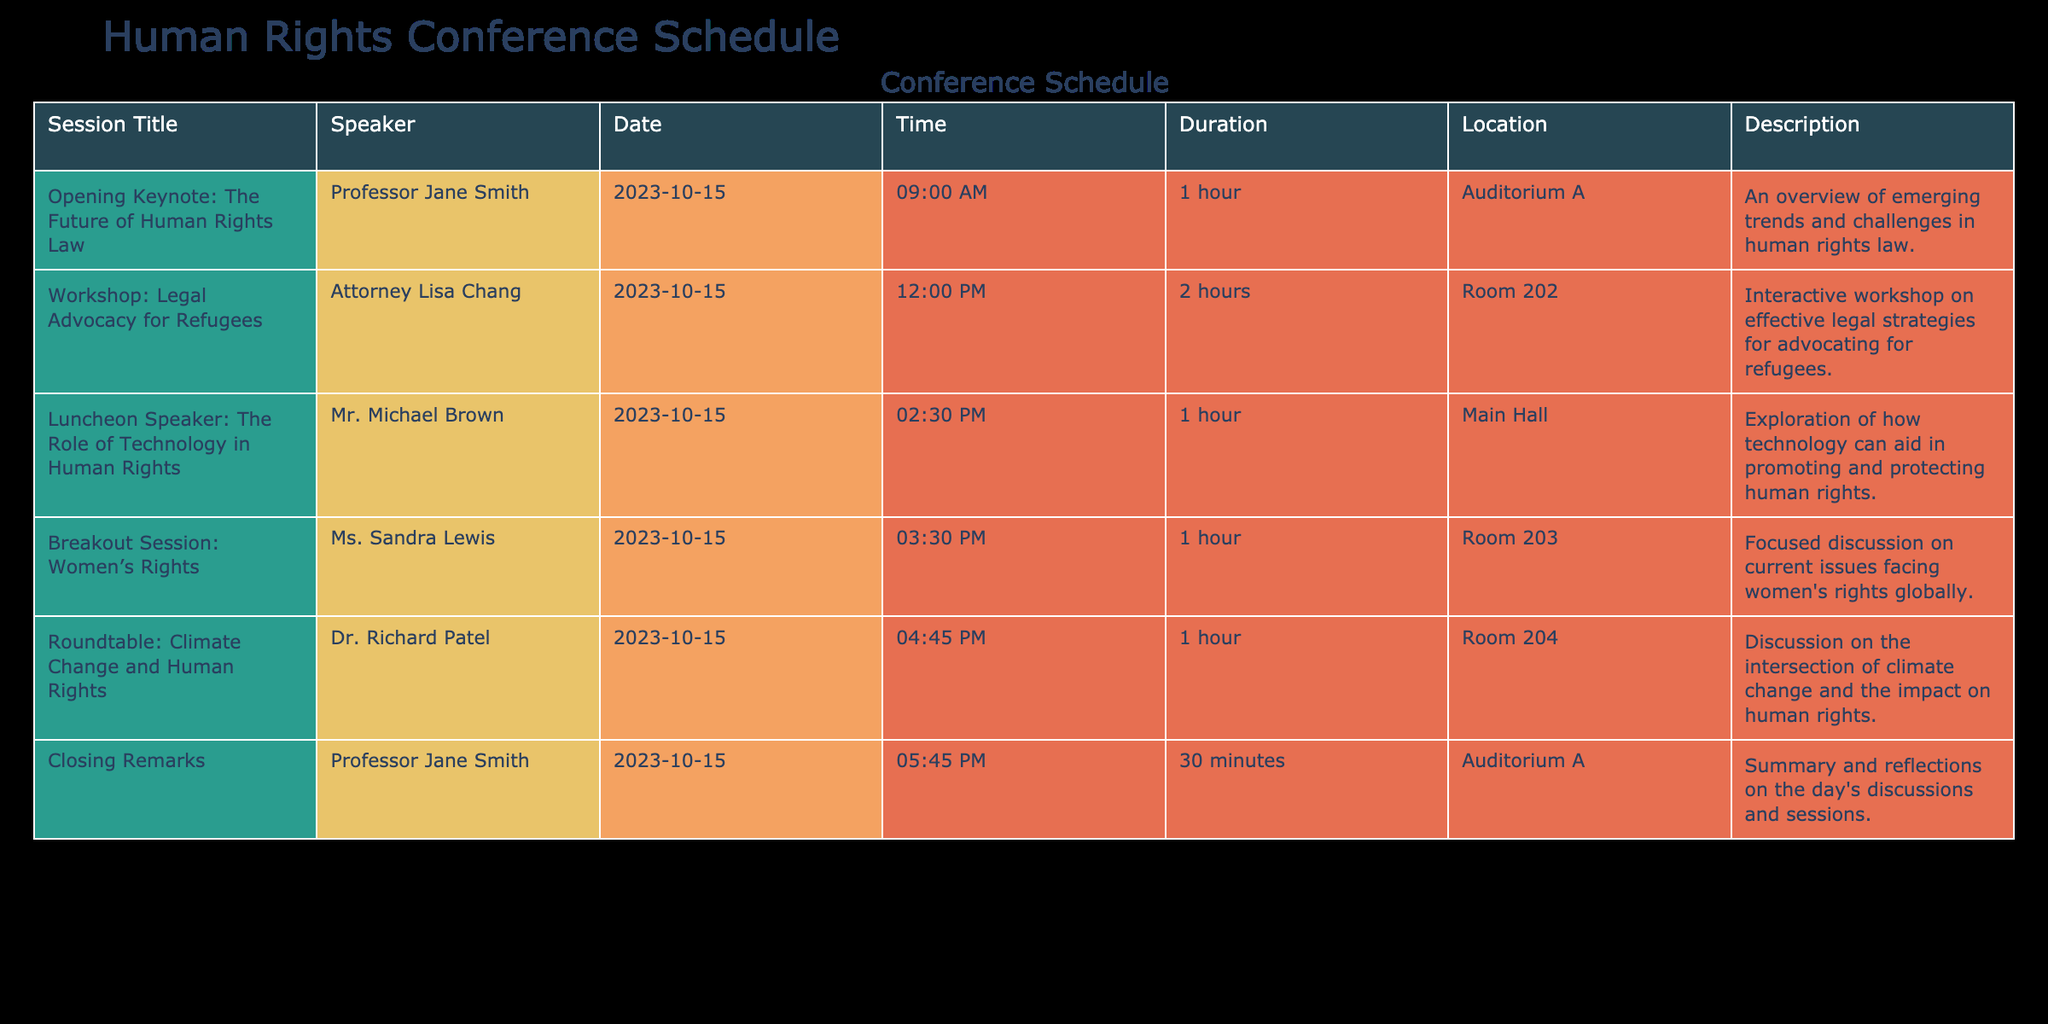What is the title of the opening keynote session? The title of the opening keynote session is listed in the first row of the table under the column "Session Title." It reads "Opening Keynote: The Future of Human Rights Law."
Answer: Opening Keynote: The Future of Human Rights Law Who is the speaker for the workshop on legal advocacy for refugees? The speaker's name is found in the second row of the table under the column "Speaker." The speaker for the workshop is Attorney Lisa Chang.
Answer: Attorney Lisa Chang What is the total duration of the sessions scheduled for October 15, 2023? To find the total duration, we can sum the duration of each session. The durations are 1 hour, 2 hours, 1 hour, 1 hour, 1 hour, and 0.5 hours. Converting all to hours gives: 1 + 2 + 1 + 1 + 1 + 0.5 = 6.5 hours.
Answer: 6.5 hours Is there a session about women's rights on the schedule? We need to check if there is a session with "Women's Rights" mentioned in any of the session titles. The table does show a session titled "Breakout Session: Women’s Rights," therefore the answer is yes.
Answer: Yes Which session occurs last in the schedule on October 15, 2023? The last session can be determined by looking at the "Time" column for the sessions on that date. The last time listed is "05:45 PM" associated with the "Closing Remarks" session given by Professor Jane Smith.
Answer: Closing Remarks What is the location for the roundtable discussion on climate change and human rights? The location can be found by locating the row for the "Roundtable: Climate Change and Human Rights" session and reading across to the "Location" column. The location listed is "Room 204."
Answer: Room 204 How many sessions start after 2:00 PM? We can check the "Time" column for sessions that fall after 2:00 PM. The sessions starting after that time are "Luncheon Speaker" at 2:30 PM, "Breakout Session: Women’s Rights" at 3:30 PM, "Roundtable: Climate Change and Human Rights" at 4:45 PM, and "Closing Remarks" at 5:45 PM. Thus, there are four sessions.
Answer: 4 Do any of the sessions focus on technology's role in human rights? To answer, we need to look for the word "technology" in the session titles or descriptions. The "Luncheon Speaker: The Role of Technology in Human Rights" addresses this subject, confirming the session does focus on technology's role.
Answer: Yes What is the duration of the workshop on legal advocacy for refugees, and which speaker is leading it? The duration is noted in the "Duration" column under the corresponding session title. For "Workshop: Legal Advocacy for Refugees," the duration is 2 hours and the speaker is Attorney Lisa Chang based on the "Speaker" column.
Answer: 2 hours, Attorney Lisa Chang 